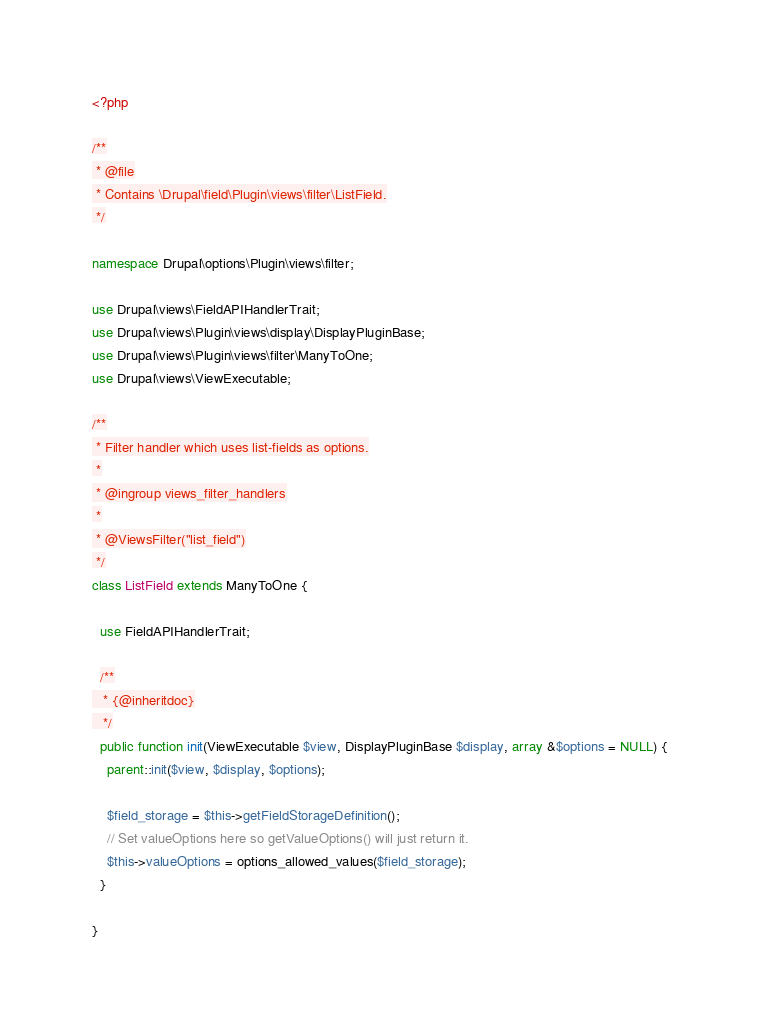<code> <loc_0><loc_0><loc_500><loc_500><_PHP_><?php

/**
 * @file
 * Contains \Drupal\field\Plugin\views\filter\ListField.
 */

namespace Drupal\options\Plugin\views\filter;

use Drupal\views\FieldAPIHandlerTrait;
use Drupal\views\Plugin\views\display\DisplayPluginBase;
use Drupal\views\Plugin\views\filter\ManyToOne;
use Drupal\views\ViewExecutable;

/**
 * Filter handler which uses list-fields as options.
 *
 * @ingroup views_filter_handlers
 *
 * @ViewsFilter("list_field")
 */
class ListField extends ManyToOne {

  use FieldAPIHandlerTrait;

  /**
   * {@inheritdoc}
   */
  public function init(ViewExecutable $view, DisplayPluginBase $display, array &$options = NULL) {
    parent::init($view, $display, $options);

    $field_storage = $this->getFieldStorageDefinition();
    // Set valueOptions here so getValueOptions() will just return it.
    $this->valueOptions = options_allowed_values($field_storage);
  }

}
</code> 